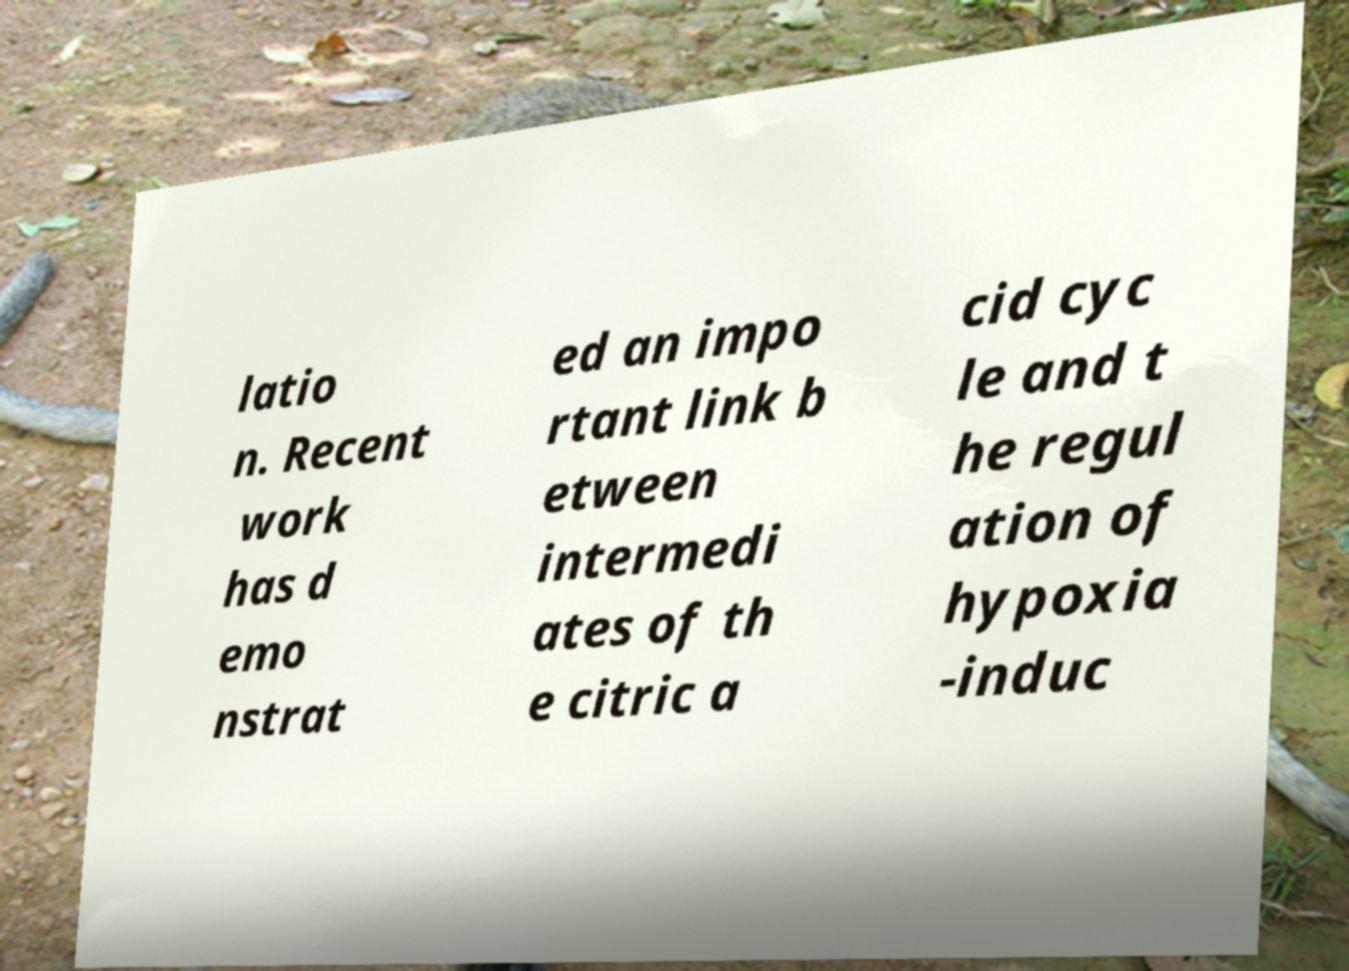Can you accurately transcribe the text from the provided image for me? latio n. Recent work has d emo nstrat ed an impo rtant link b etween intermedi ates of th e citric a cid cyc le and t he regul ation of hypoxia -induc 